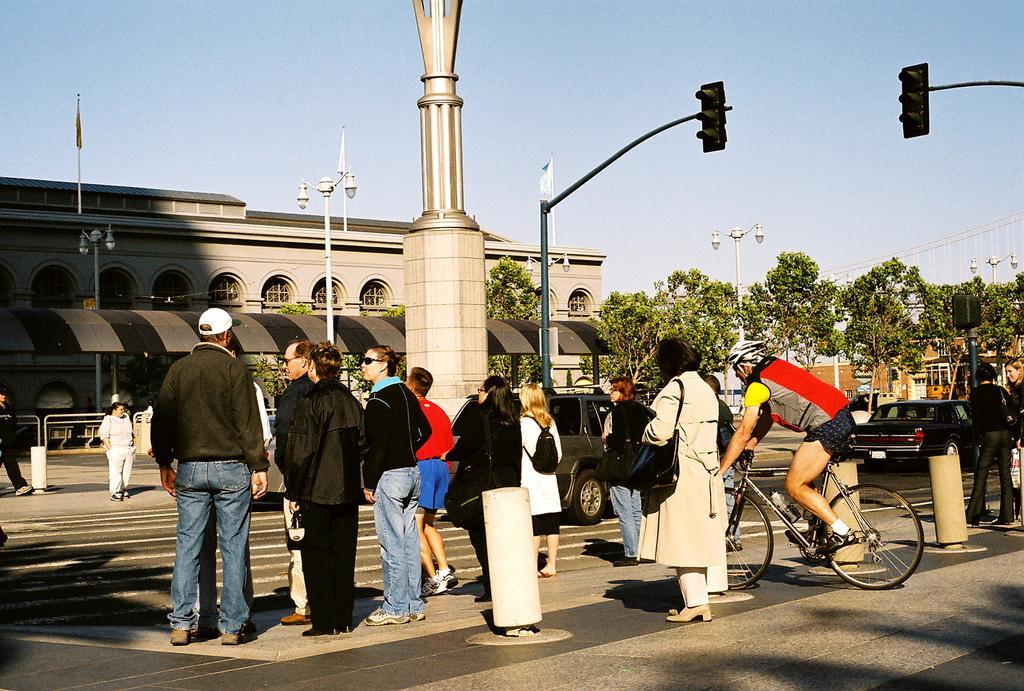Please provide a concise description of this image. This is a picture of outside of the city, in this picture in the foreground there are some people who are standing and one person is sitting on a cycle and also there are some poles and traffic signals. In the background there are some buildings and poles and lights, at the bottom there is a road and on the right side there is one car. On the top of the image there is sky. 